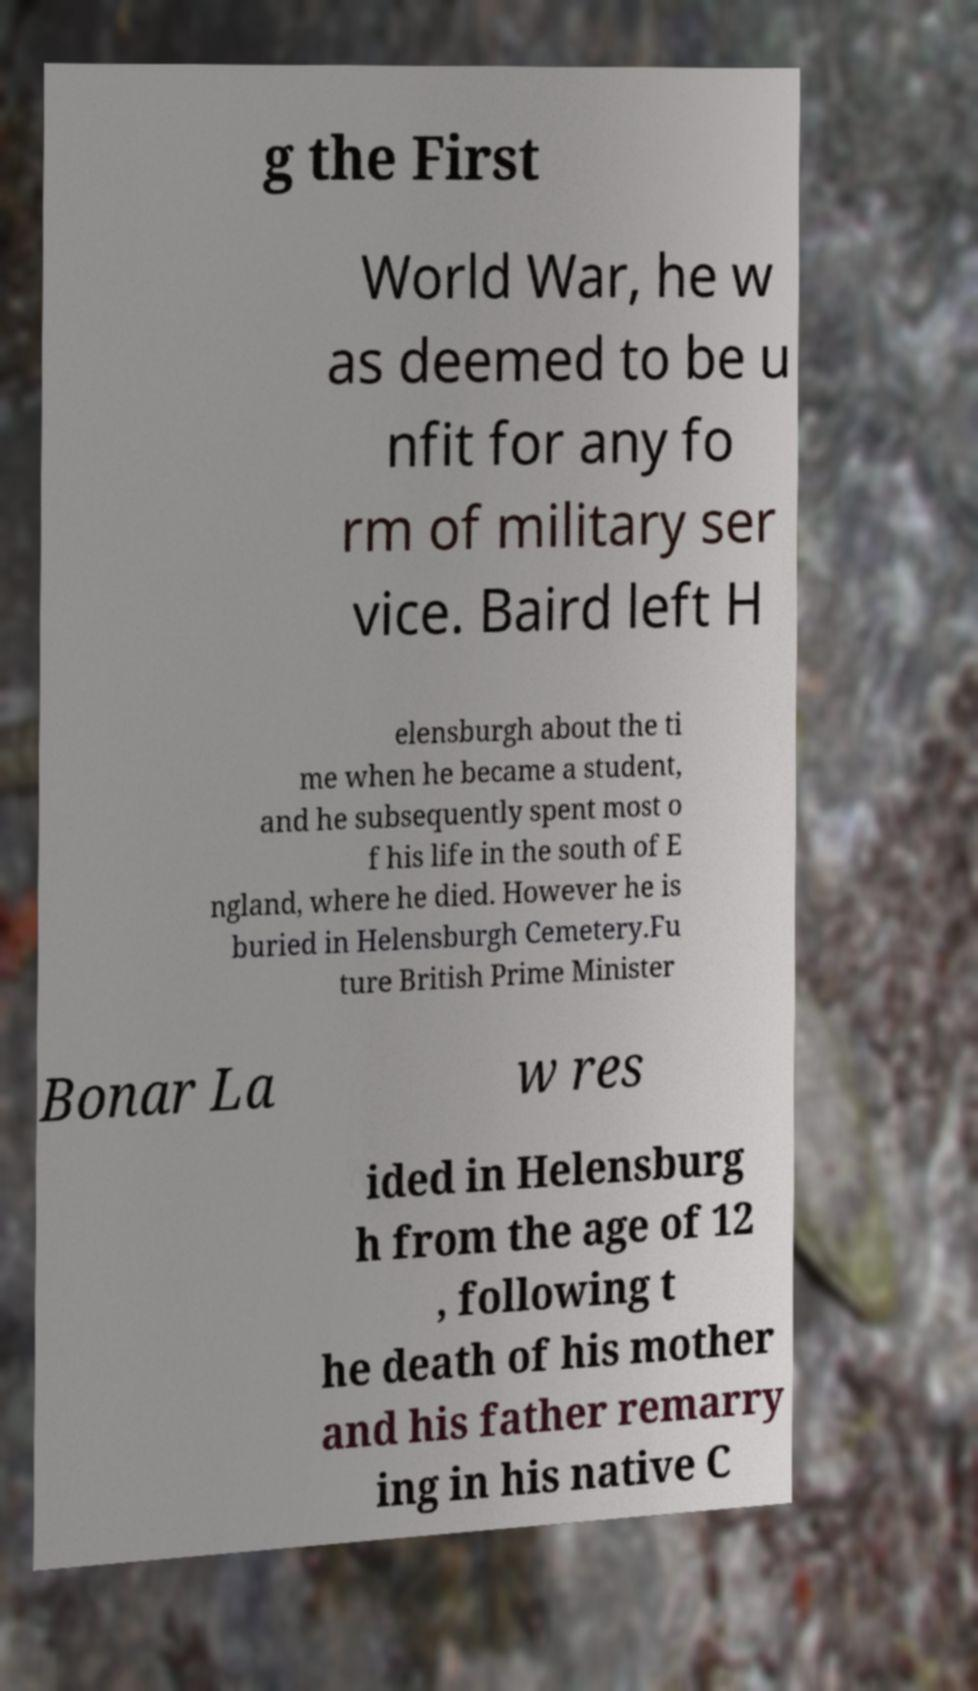I need the written content from this picture converted into text. Can you do that? g the First World War, he w as deemed to be u nfit for any fo rm of military ser vice. Baird left H elensburgh about the ti me when he became a student, and he subsequently spent most o f his life in the south of E ngland, where he died. However he is buried in Helensburgh Cemetery.Fu ture British Prime Minister Bonar La w res ided in Helensburg h from the age of 12 , following t he death of his mother and his father remarry ing in his native C 